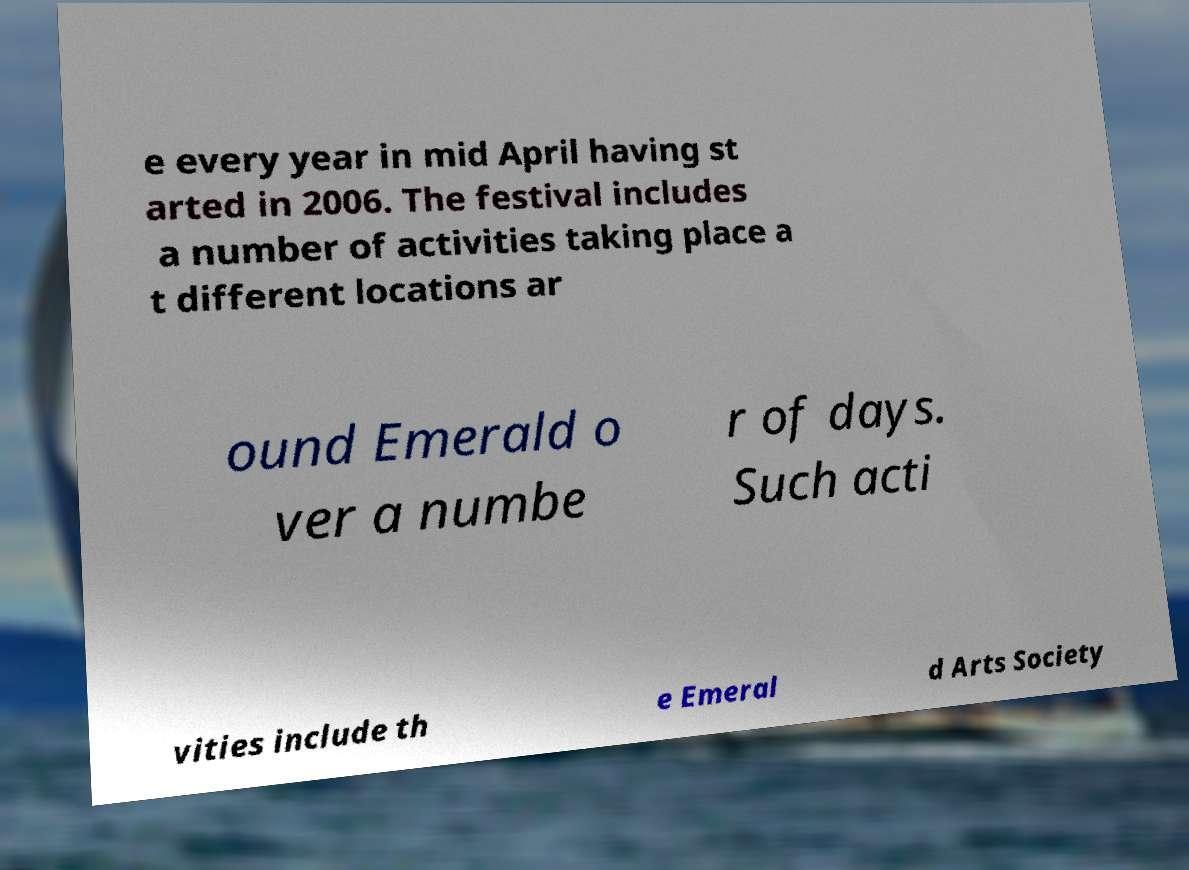There's text embedded in this image that I need extracted. Can you transcribe it verbatim? e every year in mid April having st arted in 2006. The festival includes a number of activities taking place a t different locations ar ound Emerald o ver a numbe r of days. Such acti vities include th e Emeral d Arts Society 